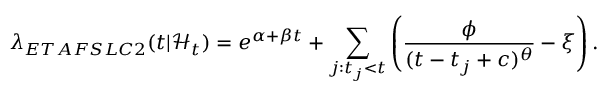Convert formula to latex. <formula><loc_0><loc_0><loc_500><loc_500>\lambda _ { E T A F S L C 2 } ( t | \mathcal { H } _ { t } ) = e ^ { \alpha + \beta t } + \sum _ { j \colon t _ { j } < t } \left ( \frac { \phi } { ( t - t _ { j } + c ) ^ { \theta } } - \xi \right ) .</formula> 